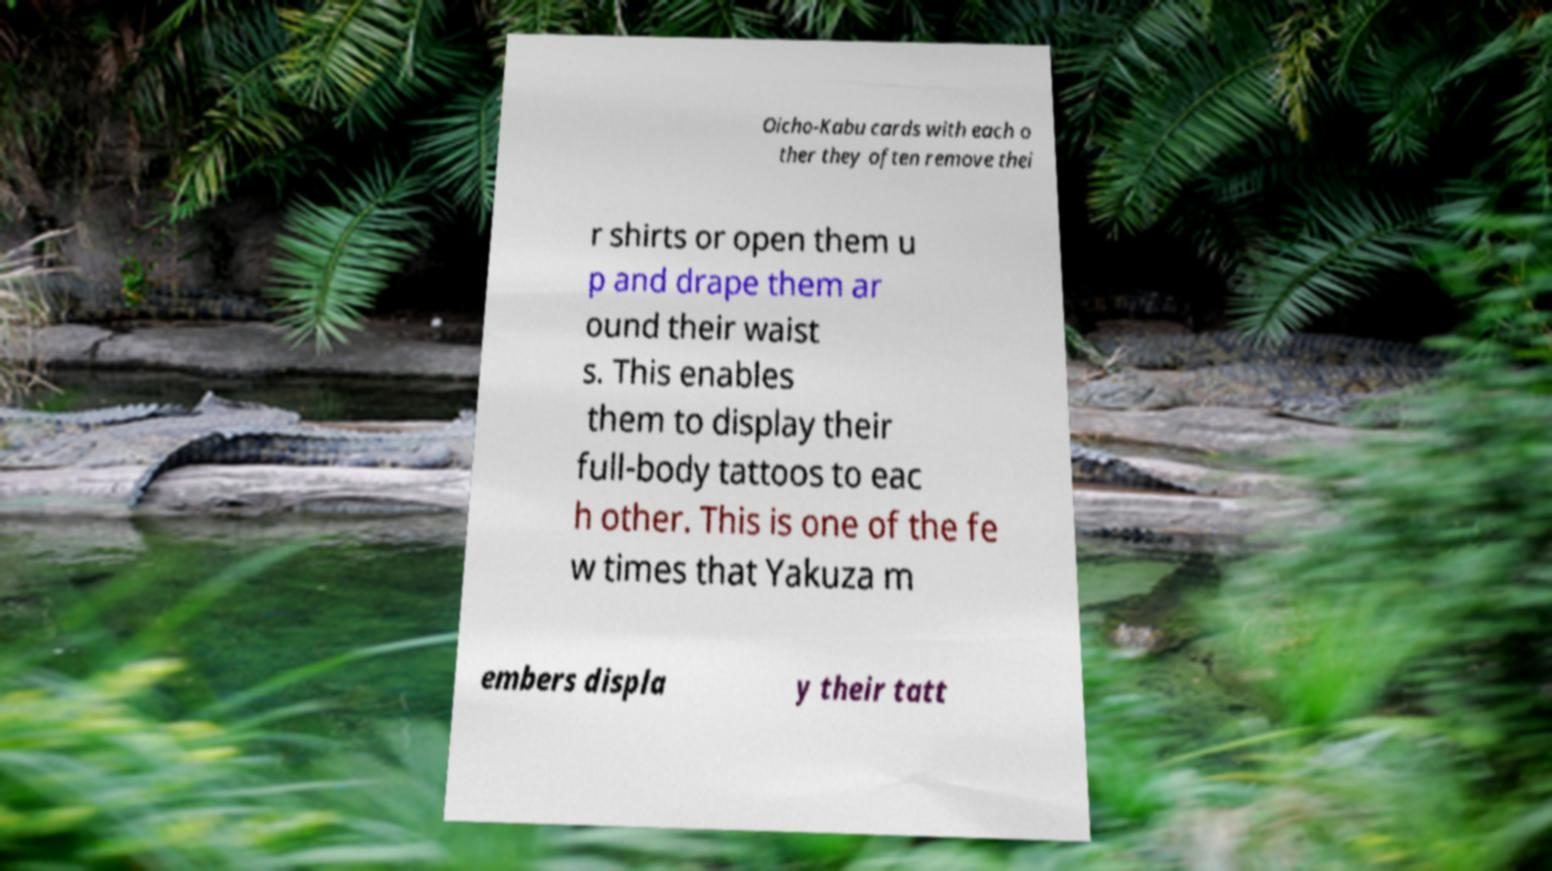There's text embedded in this image that I need extracted. Can you transcribe it verbatim? Oicho-Kabu cards with each o ther they often remove thei r shirts or open them u p and drape them ar ound their waist s. This enables them to display their full-body tattoos to eac h other. This is one of the fe w times that Yakuza m embers displa y their tatt 